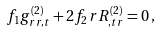Convert formula to latex. <formula><loc_0><loc_0><loc_500><loc_500>f _ { 1 } g ^ { ( 2 ) } _ { r r , t } + 2 f _ { 2 } r R ^ { ( 2 ) } _ { , t r } = 0 \, ,</formula> 